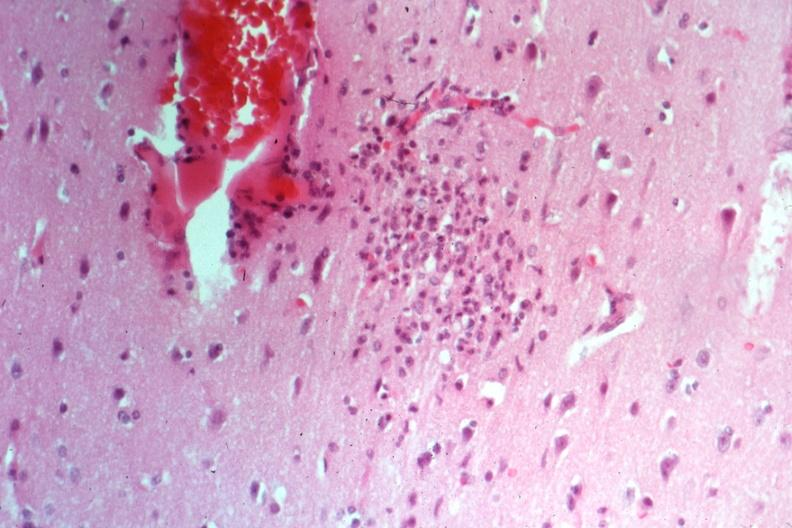what does this image show?
Answer the question using a single word or phrase. Typical nodule cause not known at time 